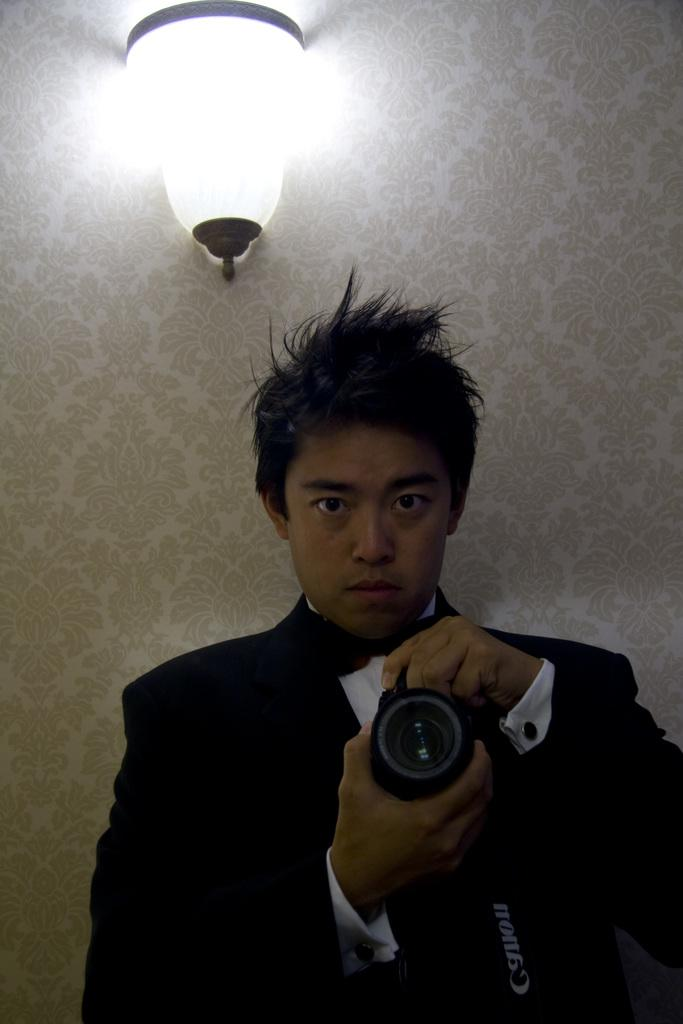What is present in the image? There is a man in the image. What is the man holding in his hand? The man is holding a camera in his hand. Can you describe any other objects or features in the image? There is a light on a wall in the image. What type of seed can be seen growing near the man in the image? There is no seed present in the image. Can you tell me how many kittens are visible in the image? There are no kittens present in the image. 